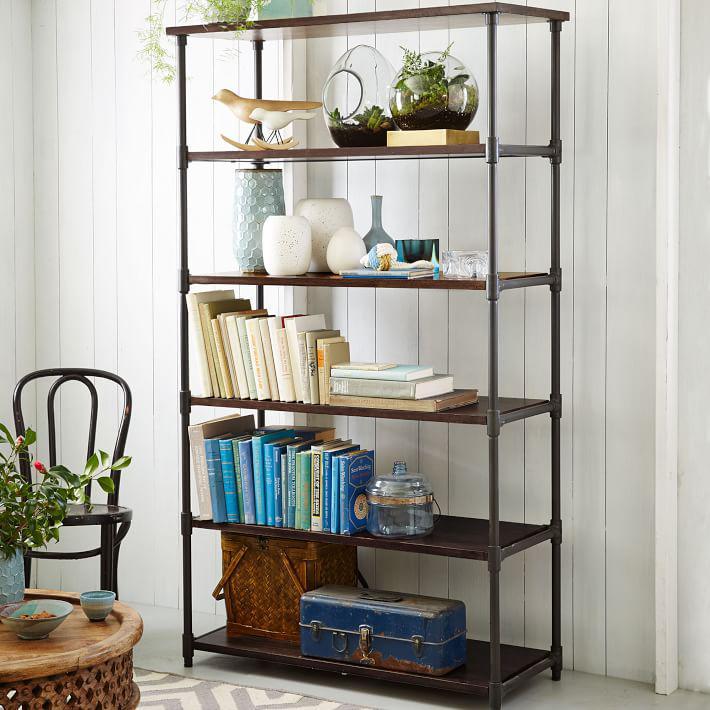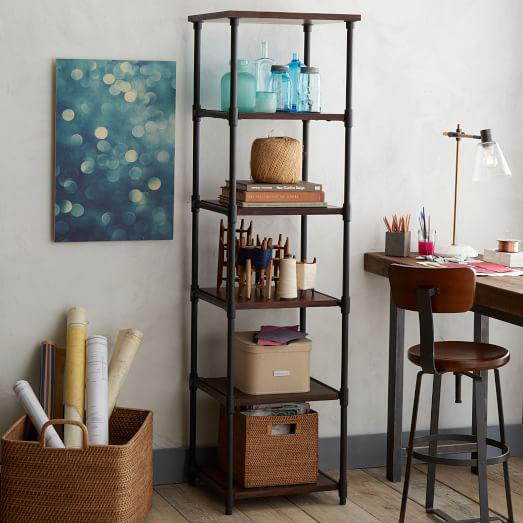The first image is the image on the left, the second image is the image on the right. Considering the images on both sides, is "An image shows a completely empty set of shelves." valid? Answer yes or no. No. The first image is the image on the left, the second image is the image on the right. Considering the images on both sides, is "One of the images shows a bookshelf that is empty." valid? Answer yes or no. No. 